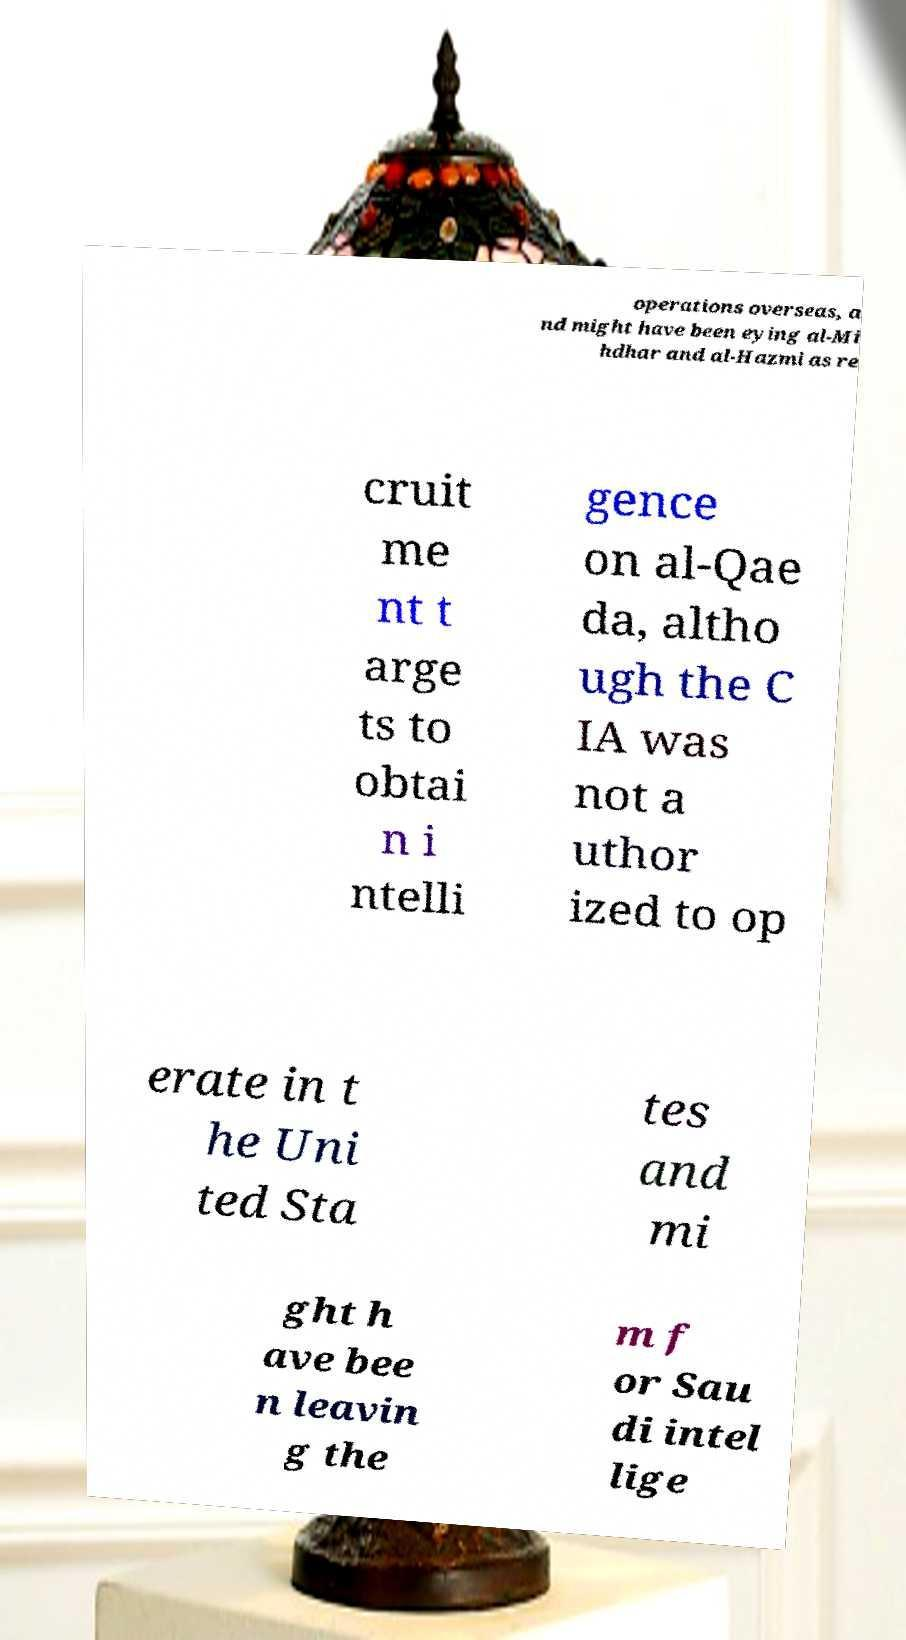Could you extract and type out the text from this image? operations overseas, a nd might have been eying al-Mi hdhar and al-Hazmi as re cruit me nt t arge ts to obtai n i ntelli gence on al-Qae da, altho ugh the C IA was not a uthor ized to op erate in t he Uni ted Sta tes and mi ght h ave bee n leavin g the m f or Sau di intel lige 